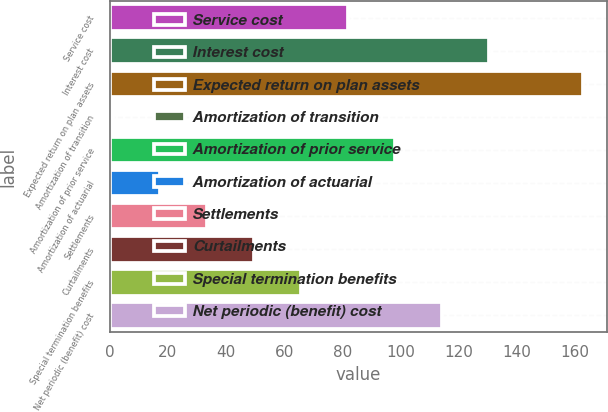<chart> <loc_0><loc_0><loc_500><loc_500><bar_chart><fcel>Service cost<fcel>Interest cost<fcel>Expected return on plan assets<fcel>Amortization of transition<fcel>Amortization of prior service<fcel>Amortization of actuarial<fcel>Settlements<fcel>Curtailments<fcel>Special termination benefits<fcel>Net periodic (benefit) cost<nl><fcel>82<fcel>130.6<fcel>163<fcel>1<fcel>98.2<fcel>17.2<fcel>33.4<fcel>49.6<fcel>65.8<fcel>114.4<nl></chart> 